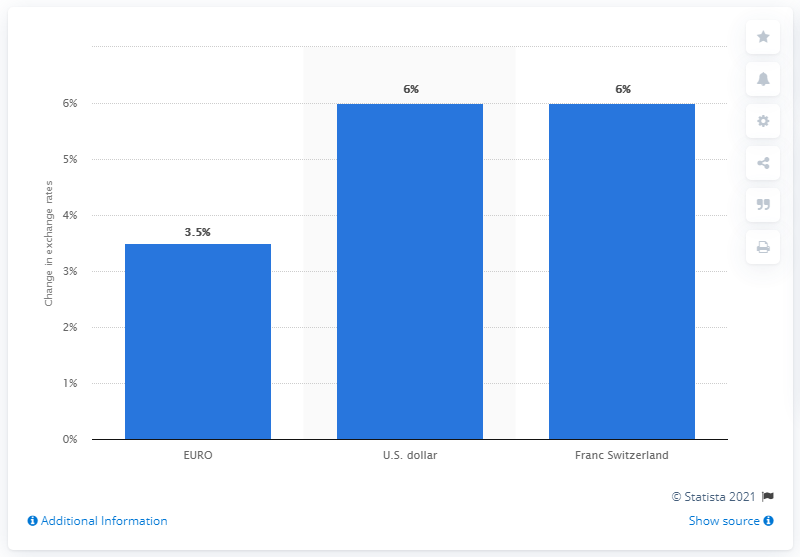Point out several critical features in this image. The euro's exchange rate increased by a significant amount of 3.5%. 